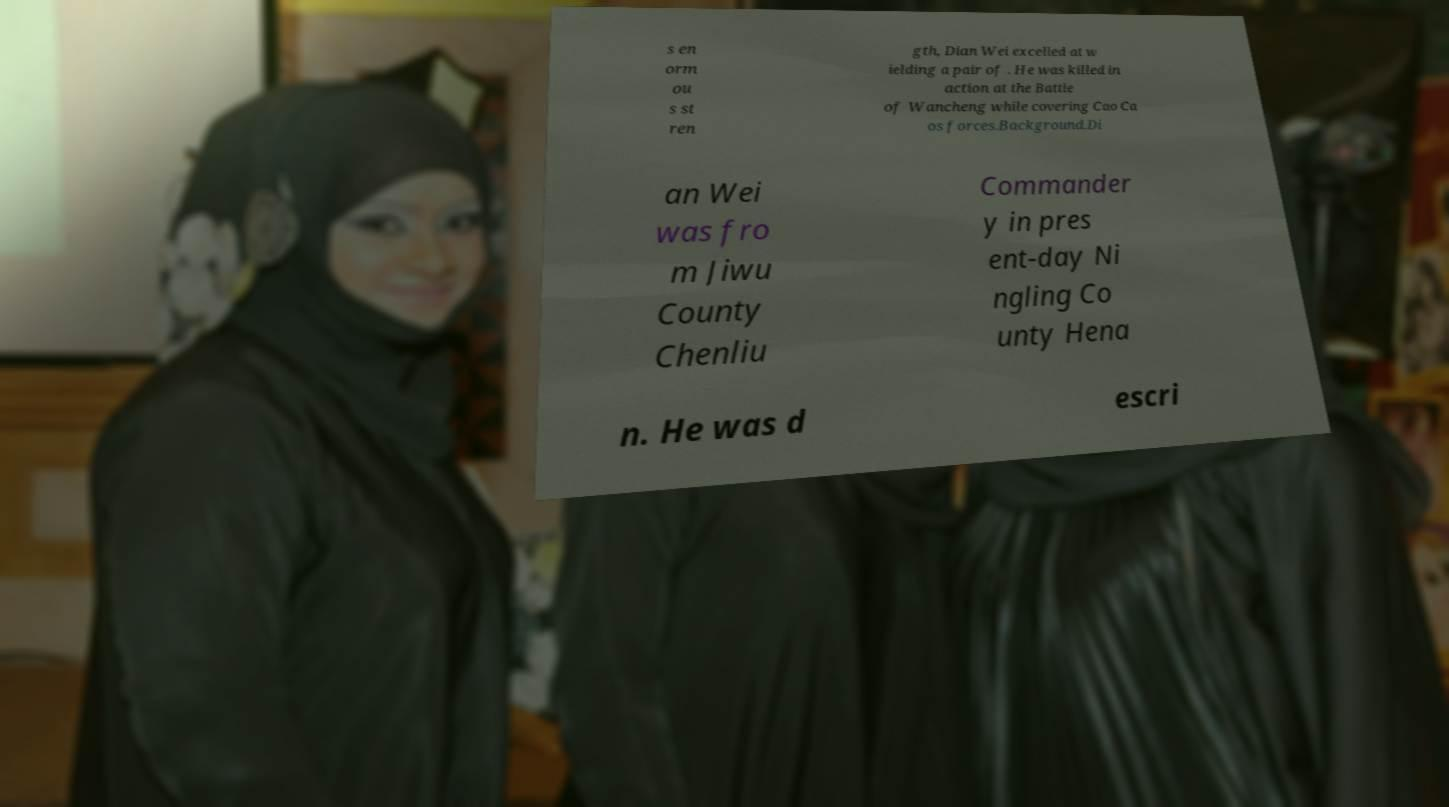Could you extract and type out the text from this image? s en orm ou s st ren gth, Dian Wei excelled at w ielding a pair of . He was killed in action at the Battle of Wancheng while covering Cao Ca os forces.Background.Di an Wei was fro m Jiwu County Chenliu Commander y in pres ent-day Ni ngling Co unty Hena n. He was d escri 